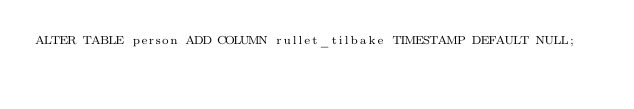Convert code to text. <code><loc_0><loc_0><loc_500><loc_500><_SQL_>ALTER TABLE person ADD COLUMN rullet_tilbake TIMESTAMP DEFAULT NULL;
</code> 